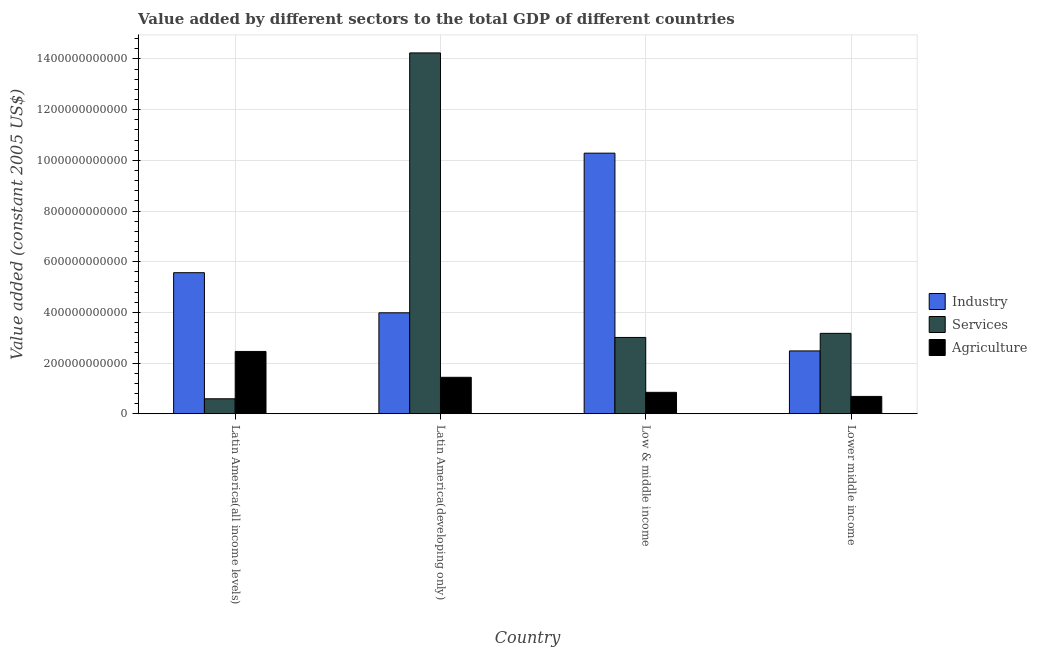How many groups of bars are there?
Give a very brief answer. 4. Are the number of bars per tick equal to the number of legend labels?
Your answer should be compact. Yes. Are the number of bars on each tick of the X-axis equal?
Offer a very short reply. Yes. How many bars are there on the 1st tick from the left?
Your answer should be very brief. 3. What is the value added by services in Latin America(developing only)?
Offer a very short reply. 1.42e+12. Across all countries, what is the maximum value added by services?
Provide a succinct answer. 1.42e+12. Across all countries, what is the minimum value added by industrial sector?
Your response must be concise. 2.48e+11. In which country was the value added by agricultural sector maximum?
Your answer should be compact. Latin America(all income levels). In which country was the value added by industrial sector minimum?
Your response must be concise. Lower middle income. What is the total value added by agricultural sector in the graph?
Your answer should be very brief. 5.42e+11. What is the difference between the value added by services in Latin America(developing only) and that in Low & middle income?
Your answer should be very brief. 1.12e+12. What is the difference between the value added by industrial sector in Lower middle income and the value added by services in Latin America(developing only)?
Ensure brevity in your answer.  -1.18e+12. What is the average value added by services per country?
Your response must be concise. 5.25e+11. What is the difference between the value added by industrial sector and value added by services in Latin America(all income levels)?
Your answer should be compact. 4.98e+11. What is the ratio of the value added by agricultural sector in Latin America(all income levels) to that in Latin America(developing only)?
Offer a terse response. 1.71. What is the difference between the highest and the second highest value added by industrial sector?
Give a very brief answer. 4.72e+11. What is the difference between the highest and the lowest value added by services?
Make the answer very short. 1.36e+12. Is the sum of the value added by industrial sector in Latin America(all income levels) and Lower middle income greater than the maximum value added by agricultural sector across all countries?
Ensure brevity in your answer.  Yes. What does the 1st bar from the left in Lower middle income represents?
Your answer should be very brief. Industry. What does the 2nd bar from the right in Latin America(all income levels) represents?
Keep it short and to the point. Services. How many bars are there?
Keep it short and to the point. 12. How many countries are there in the graph?
Your response must be concise. 4. What is the difference between two consecutive major ticks on the Y-axis?
Offer a terse response. 2.00e+11. Are the values on the major ticks of Y-axis written in scientific E-notation?
Keep it short and to the point. No. Does the graph contain any zero values?
Your answer should be compact. No. Where does the legend appear in the graph?
Offer a terse response. Center right. What is the title of the graph?
Your answer should be very brief. Value added by different sectors to the total GDP of different countries. What is the label or title of the X-axis?
Make the answer very short. Country. What is the label or title of the Y-axis?
Make the answer very short. Value added (constant 2005 US$). What is the Value added (constant 2005 US$) in Industry in Latin America(all income levels)?
Ensure brevity in your answer.  5.57e+11. What is the Value added (constant 2005 US$) of Services in Latin America(all income levels)?
Offer a terse response. 5.90e+1. What is the Value added (constant 2005 US$) in Agriculture in Latin America(all income levels)?
Offer a terse response. 2.46e+11. What is the Value added (constant 2005 US$) of Industry in Latin America(developing only)?
Provide a succinct answer. 3.98e+11. What is the Value added (constant 2005 US$) in Services in Latin America(developing only)?
Ensure brevity in your answer.  1.42e+12. What is the Value added (constant 2005 US$) of Agriculture in Latin America(developing only)?
Give a very brief answer. 1.44e+11. What is the Value added (constant 2005 US$) in Industry in Low & middle income?
Your answer should be very brief. 1.03e+12. What is the Value added (constant 2005 US$) of Services in Low & middle income?
Give a very brief answer. 3.01e+11. What is the Value added (constant 2005 US$) of Agriculture in Low & middle income?
Offer a very short reply. 8.44e+1. What is the Value added (constant 2005 US$) in Industry in Lower middle income?
Provide a succinct answer. 2.48e+11. What is the Value added (constant 2005 US$) in Services in Lower middle income?
Your response must be concise. 3.17e+11. What is the Value added (constant 2005 US$) of Agriculture in Lower middle income?
Your answer should be very brief. 6.83e+1. Across all countries, what is the maximum Value added (constant 2005 US$) in Industry?
Your answer should be compact. 1.03e+12. Across all countries, what is the maximum Value added (constant 2005 US$) of Services?
Offer a very short reply. 1.42e+12. Across all countries, what is the maximum Value added (constant 2005 US$) of Agriculture?
Make the answer very short. 2.46e+11. Across all countries, what is the minimum Value added (constant 2005 US$) of Industry?
Your response must be concise. 2.48e+11. Across all countries, what is the minimum Value added (constant 2005 US$) of Services?
Ensure brevity in your answer.  5.90e+1. Across all countries, what is the minimum Value added (constant 2005 US$) of Agriculture?
Offer a terse response. 6.83e+1. What is the total Value added (constant 2005 US$) in Industry in the graph?
Offer a very short reply. 2.23e+12. What is the total Value added (constant 2005 US$) of Services in the graph?
Your response must be concise. 2.10e+12. What is the total Value added (constant 2005 US$) of Agriculture in the graph?
Provide a short and direct response. 5.42e+11. What is the difference between the Value added (constant 2005 US$) in Industry in Latin America(all income levels) and that in Latin America(developing only)?
Ensure brevity in your answer.  1.58e+11. What is the difference between the Value added (constant 2005 US$) of Services in Latin America(all income levels) and that in Latin America(developing only)?
Give a very brief answer. -1.36e+12. What is the difference between the Value added (constant 2005 US$) of Agriculture in Latin America(all income levels) and that in Latin America(developing only)?
Offer a terse response. 1.02e+11. What is the difference between the Value added (constant 2005 US$) of Industry in Latin America(all income levels) and that in Low & middle income?
Provide a short and direct response. -4.72e+11. What is the difference between the Value added (constant 2005 US$) in Services in Latin America(all income levels) and that in Low & middle income?
Give a very brief answer. -2.42e+11. What is the difference between the Value added (constant 2005 US$) of Agriculture in Latin America(all income levels) and that in Low & middle income?
Give a very brief answer. 1.61e+11. What is the difference between the Value added (constant 2005 US$) of Industry in Latin America(all income levels) and that in Lower middle income?
Your answer should be compact. 3.09e+11. What is the difference between the Value added (constant 2005 US$) in Services in Latin America(all income levels) and that in Lower middle income?
Give a very brief answer. -2.58e+11. What is the difference between the Value added (constant 2005 US$) of Agriculture in Latin America(all income levels) and that in Lower middle income?
Your answer should be very brief. 1.78e+11. What is the difference between the Value added (constant 2005 US$) in Industry in Latin America(developing only) and that in Low & middle income?
Offer a very short reply. -6.30e+11. What is the difference between the Value added (constant 2005 US$) in Services in Latin America(developing only) and that in Low & middle income?
Your answer should be compact. 1.12e+12. What is the difference between the Value added (constant 2005 US$) in Agriculture in Latin America(developing only) and that in Low & middle income?
Make the answer very short. 5.93e+1. What is the difference between the Value added (constant 2005 US$) in Industry in Latin America(developing only) and that in Lower middle income?
Keep it short and to the point. 1.50e+11. What is the difference between the Value added (constant 2005 US$) in Services in Latin America(developing only) and that in Lower middle income?
Make the answer very short. 1.11e+12. What is the difference between the Value added (constant 2005 US$) of Agriculture in Latin America(developing only) and that in Lower middle income?
Provide a succinct answer. 7.54e+1. What is the difference between the Value added (constant 2005 US$) of Industry in Low & middle income and that in Lower middle income?
Give a very brief answer. 7.80e+11. What is the difference between the Value added (constant 2005 US$) of Services in Low & middle income and that in Lower middle income?
Provide a short and direct response. -1.62e+1. What is the difference between the Value added (constant 2005 US$) in Agriculture in Low & middle income and that in Lower middle income?
Keep it short and to the point. 1.61e+1. What is the difference between the Value added (constant 2005 US$) of Industry in Latin America(all income levels) and the Value added (constant 2005 US$) of Services in Latin America(developing only)?
Ensure brevity in your answer.  -8.67e+11. What is the difference between the Value added (constant 2005 US$) in Industry in Latin America(all income levels) and the Value added (constant 2005 US$) in Agriculture in Latin America(developing only)?
Give a very brief answer. 4.13e+11. What is the difference between the Value added (constant 2005 US$) in Services in Latin America(all income levels) and the Value added (constant 2005 US$) in Agriculture in Latin America(developing only)?
Give a very brief answer. -8.48e+1. What is the difference between the Value added (constant 2005 US$) of Industry in Latin America(all income levels) and the Value added (constant 2005 US$) of Services in Low & middle income?
Provide a succinct answer. 2.56e+11. What is the difference between the Value added (constant 2005 US$) in Industry in Latin America(all income levels) and the Value added (constant 2005 US$) in Agriculture in Low & middle income?
Offer a terse response. 4.72e+11. What is the difference between the Value added (constant 2005 US$) in Services in Latin America(all income levels) and the Value added (constant 2005 US$) in Agriculture in Low & middle income?
Provide a short and direct response. -2.55e+1. What is the difference between the Value added (constant 2005 US$) in Industry in Latin America(all income levels) and the Value added (constant 2005 US$) in Services in Lower middle income?
Your answer should be compact. 2.39e+11. What is the difference between the Value added (constant 2005 US$) in Industry in Latin America(all income levels) and the Value added (constant 2005 US$) in Agriculture in Lower middle income?
Your answer should be compact. 4.88e+11. What is the difference between the Value added (constant 2005 US$) of Services in Latin America(all income levels) and the Value added (constant 2005 US$) of Agriculture in Lower middle income?
Ensure brevity in your answer.  -9.35e+09. What is the difference between the Value added (constant 2005 US$) in Industry in Latin America(developing only) and the Value added (constant 2005 US$) in Services in Low & middle income?
Offer a terse response. 9.73e+1. What is the difference between the Value added (constant 2005 US$) in Industry in Latin America(developing only) and the Value added (constant 2005 US$) in Agriculture in Low & middle income?
Provide a short and direct response. 3.14e+11. What is the difference between the Value added (constant 2005 US$) in Services in Latin America(developing only) and the Value added (constant 2005 US$) in Agriculture in Low & middle income?
Your answer should be compact. 1.34e+12. What is the difference between the Value added (constant 2005 US$) in Industry in Latin America(developing only) and the Value added (constant 2005 US$) in Services in Lower middle income?
Provide a succinct answer. 8.11e+1. What is the difference between the Value added (constant 2005 US$) in Industry in Latin America(developing only) and the Value added (constant 2005 US$) in Agriculture in Lower middle income?
Provide a short and direct response. 3.30e+11. What is the difference between the Value added (constant 2005 US$) in Services in Latin America(developing only) and the Value added (constant 2005 US$) in Agriculture in Lower middle income?
Ensure brevity in your answer.  1.36e+12. What is the difference between the Value added (constant 2005 US$) of Industry in Low & middle income and the Value added (constant 2005 US$) of Services in Lower middle income?
Offer a very short reply. 7.11e+11. What is the difference between the Value added (constant 2005 US$) in Industry in Low & middle income and the Value added (constant 2005 US$) in Agriculture in Lower middle income?
Provide a succinct answer. 9.60e+11. What is the difference between the Value added (constant 2005 US$) in Services in Low & middle income and the Value added (constant 2005 US$) in Agriculture in Lower middle income?
Provide a short and direct response. 2.33e+11. What is the average Value added (constant 2005 US$) in Industry per country?
Offer a very short reply. 5.58e+11. What is the average Value added (constant 2005 US$) of Services per country?
Your answer should be very brief. 5.25e+11. What is the average Value added (constant 2005 US$) in Agriculture per country?
Ensure brevity in your answer.  1.36e+11. What is the difference between the Value added (constant 2005 US$) of Industry and Value added (constant 2005 US$) of Services in Latin America(all income levels)?
Keep it short and to the point. 4.98e+11. What is the difference between the Value added (constant 2005 US$) in Industry and Value added (constant 2005 US$) in Agriculture in Latin America(all income levels)?
Make the answer very short. 3.11e+11. What is the difference between the Value added (constant 2005 US$) of Services and Value added (constant 2005 US$) of Agriculture in Latin America(all income levels)?
Give a very brief answer. -1.87e+11. What is the difference between the Value added (constant 2005 US$) of Industry and Value added (constant 2005 US$) of Services in Latin America(developing only)?
Your answer should be compact. -1.03e+12. What is the difference between the Value added (constant 2005 US$) in Industry and Value added (constant 2005 US$) in Agriculture in Latin America(developing only)?
Offer a very short reply. 2.55e+11. What is the difference between the Value added (constant 2005 US$) of Services and Value added (constant 2005 US$) of Agriculture in Latin America(developing only)?
Provide a succinct answer. 1.28e+12. What is the difference between the Value added (constant 2005 US$) of Industry and Value added (constant 2005 US$) of Services in Low & middle income?
Offer a terse response. 7.27e+11. What is the difference between the Value added (constant 2005 US$) of Industry and Value added (constant 2005 US$) of Agriculture in Low & middle income?
Give a very brief answer. 9.44e+11. What is the difference between the Value added (constant 2005 US$) of Services and Value added (constant 2005 US$) of Agriculture in Low & middle income?
Provide a short and direct response. 2.17e+11. What is the difference between the Value added (constant 2005 US$) of Industry and Value added (constant 2005 US$) of Services in Lower middle income?
Your answer should be very brief. -6.94e+1. What is the difference between the Value added (constant 2005 US$) in Industry and Value added (constant 2005 US$) in Agriculture in Lower middle income?
Provide a short and direct response. 1.80e+11. What is the difference between the Value added (constant 2005 US$) of Services and Value added (constant 2005 US$) of Agriculture in Lower middle income?
Provide a succinct answer. 2.49e+11. What is the ratio of the Value added (constant 2005 US$) in Industry in Latin America(all income levels) to that in Latin America(developing only)?
Offer a terse response. 1.4. What is the ratio of the Value added (constant 2005 US$) of Services in Latin America(all income levels) to that in Latin America(developing only)?
Your response must be concise. 0.04. What is the ratio of the Value added (constant 2005 US$) in Agriculture in Latin America(all income levels) to that in Latin America(developing only)?
Provide a succinct answer. 1.71. What is the ratio of the Value added (constant 2005 US$) of Industry in Latin America(all income levels) to that in Low & middle income?
Make the answer very short. 0.54. What is the ratio of the Value added (constant 2005 US$) in Services in Latin America(all income levels) to that in Low & middle income?
Your answer should be very brief. 0.2. What is the ratio of the Value added (constant 2005 US$) in Agriculture in Latin America(all income levels) to that in Low & middle income?
Your response must be concise. 2.91. What is the ratio of the Value added (constant 2005 US$) of Industry in Latin America(all income levels) to that in Lower middle income?
Your response must be concise. 2.25. What is the ratio of the Value added (constant 2005 US$) of Services in Latin America(all income levels) to that in Lower middle income?
Make the answer very short. 0.19. What is the ratio of the Value added (constant 2005 US$) of Agriculture in Latin America(all income levels) to that in Lower middle income?
Your answer should be compact. 3.6. What is the ratio of the Value added (constant 2005 US$) of Industry in Latin America(developing only) to that in Low & middle income?
Your response must be concise. 0.39. What is the ratio of the Value added (constant 2005 US$) in Services in Latin America(developing only) to that in Low & middle income?
Your answer should be very brief. 4.73. What is the ratio of the Value added (constant 2005 US$) in Agriculture in Latin America(developing only) to that in Low & middle income?
Provide a succinct answer. 1.7. What is the ratio of the Value added (constant 2005 US$) in Industry in Latin America(developing only) to that in Lower middle income?
Keep it short and to the point. 1.61. What is the ratio of the Value added (constant 2005 US$) of Services in Latin America(developing only) to that in Lower middle income?
Keep it short and to the point. 4.49. What is the ratio of the Value added (constant 2005 US$) in Agriculture in Latin America(developing only) to that in Lower middle income?
Your response must be concise. 2.1. What is the ratio of the Value added (constant 2005 US$) of Industry in Low & middle income to that in Lower middle income?
Keep it short and to the point. 4.15. What is the ratio of the Value added (constant 2005 US$) in Services in Low & middle income to that in Lower middle income?
Offer a terse response. 0.95. What is the ratio of the Value added (constant 2005 US$) of Agriculture in Low & middle income to that in Lower middle income?
Your answer should be very brief. 1.24. What is the difference between the highest and the second highest Value added (constant 2005 US$) in Industry?
Your answer should be very brief. 4.72e+11. What is the difference between the highest and the second highest Value added (constant 2005 US$) of Services?
Ensure brevity in your answer.  1.11e+12. What is the difference between the highest and the second highest Value added (constant 2005 US$) in Agriculture?
Ensure brevity in your answer.  1.02e+11. What is the difference between the highest and the lowest Value added (constant 2005 US$) in Industry?
Your response must be concise. 7.80e+11. What is the difference between the highest and the lowest Value added (constant 2005 US$) in Services?
Your answer should be compact. 1.36e+12. What is the difference between the highest and the lowest Value added (constant 2005 US$) in Agriculture?
Keep it short and to the point. 1.78e+11. 